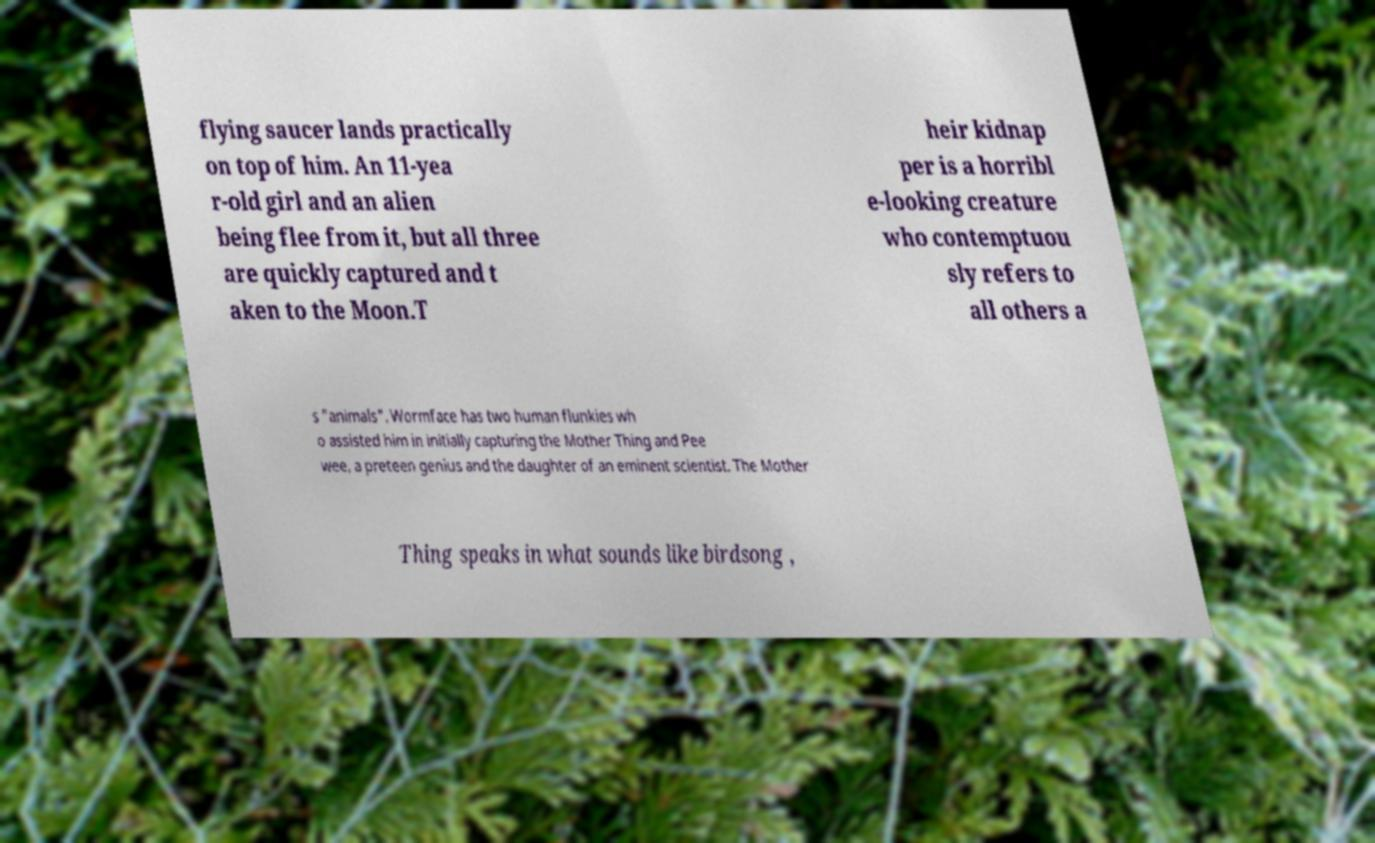Can you read and provide the text displayed in the image?This photo seems to have some interesting text. Can you extract and type it out for me? flying saucer lands practically on top of him. An 11-yea r-old girl and an alien being flee from it, but all three are quickly captured and t aken to the Moon.T heir kidnap per is a horribl e-looking creature who contemptuou sly refers to all others a s "animals". Wormface has two human flunkies wh o assisted him in initially capturing the Mother Thing and Pee wee, a preteen genius and the daughter of an eminent scientist. The Mother Thing speaks in what sounds like birdsong , 